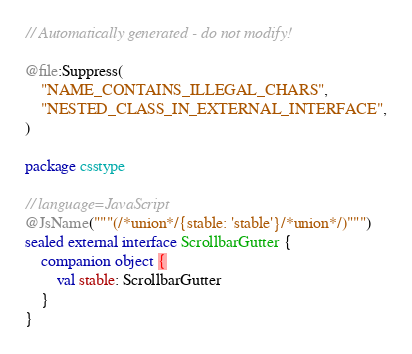<code> <loc_0><loc_0><loc_500><loc_500><_Kotlin_>// Automatically generated - do not modify!

@file:Suppress(
    "NAME_CONTAINS_ILLEGAL_CHARS",
    "NESTED_CLASS_IN_EXTERNAL_INTERFACE",
)

package csstype

// language=JavaScript
@JsName("""(/*union*/{stable: 'stable'}/*union*/)""")
sealed external interface ScrollbarGutter {
    companion object {
        val stable: ScrollbarGutter
    }
}
</code> 